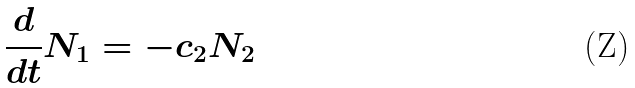<formula> <loc_0><loc_0><loc_500><loc_500>\frac { d } { d t } N _ { 1 } = - c _ { 2 } N _ { 2 }</formula> 